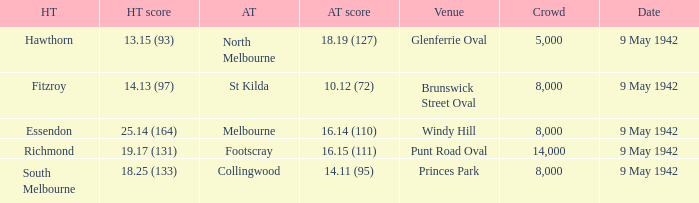How many people attended the game with the home team scoring 18.25 (133)? 1.0. 